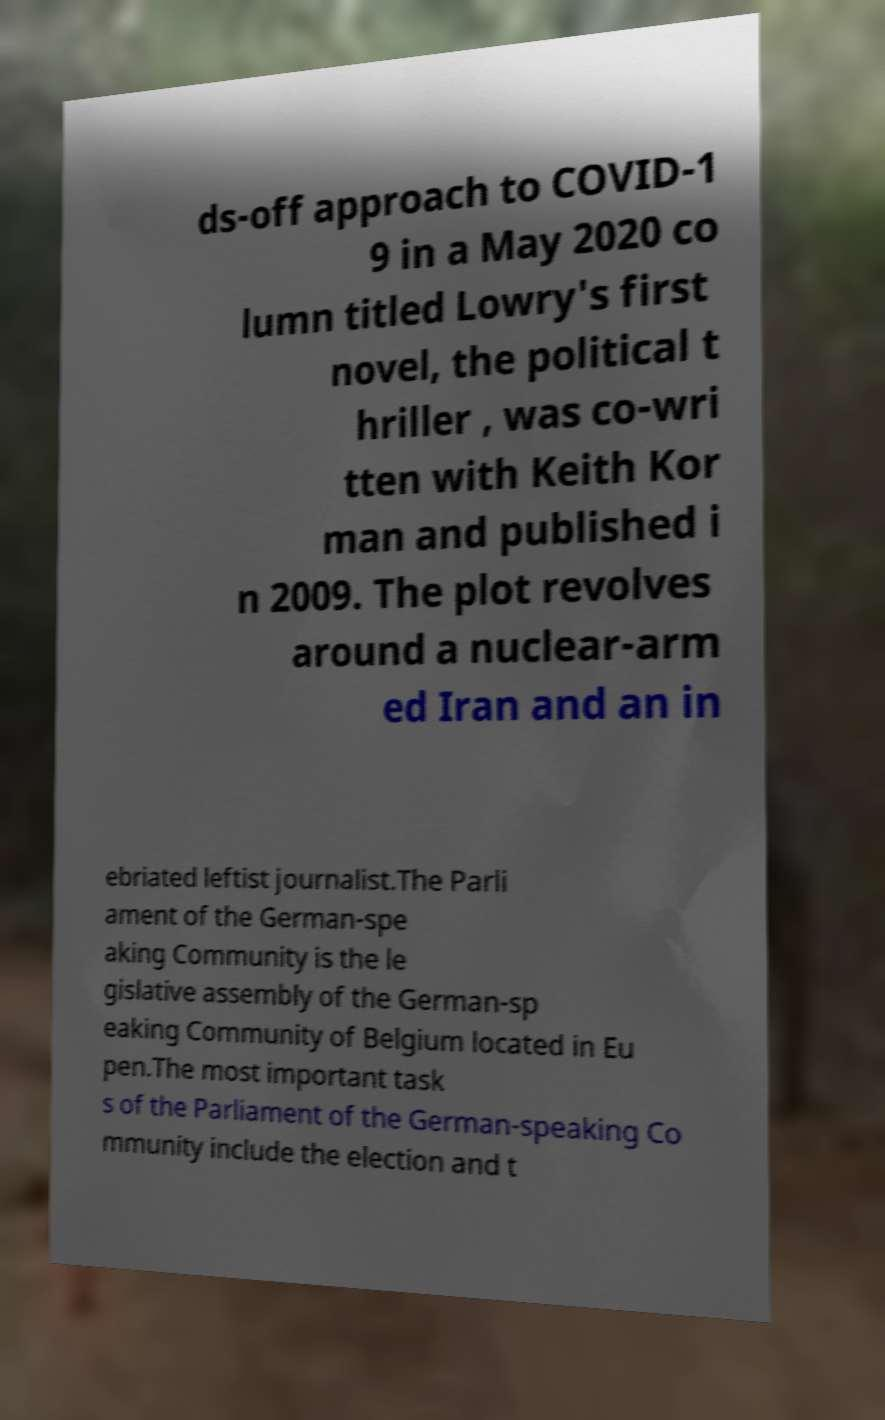Could you extract and type out the text from this image? ds-off approach to COVID-1 9 in a May 2020 co lumn titled Lowry's first novel, the political t hriller , was co-wri tten with Keith Kor man and published i n 2009. The plot revolves around a nuclear-arm ed Iran and an in ebriated leftist journalist.The Parli ament of the German-spe aking Community is the le gislative assembly of the German-sp eaking Community of Belgium located in Eu pen.The most important task s of the Parliament of the German-speaking Co mmunity include the election and t 